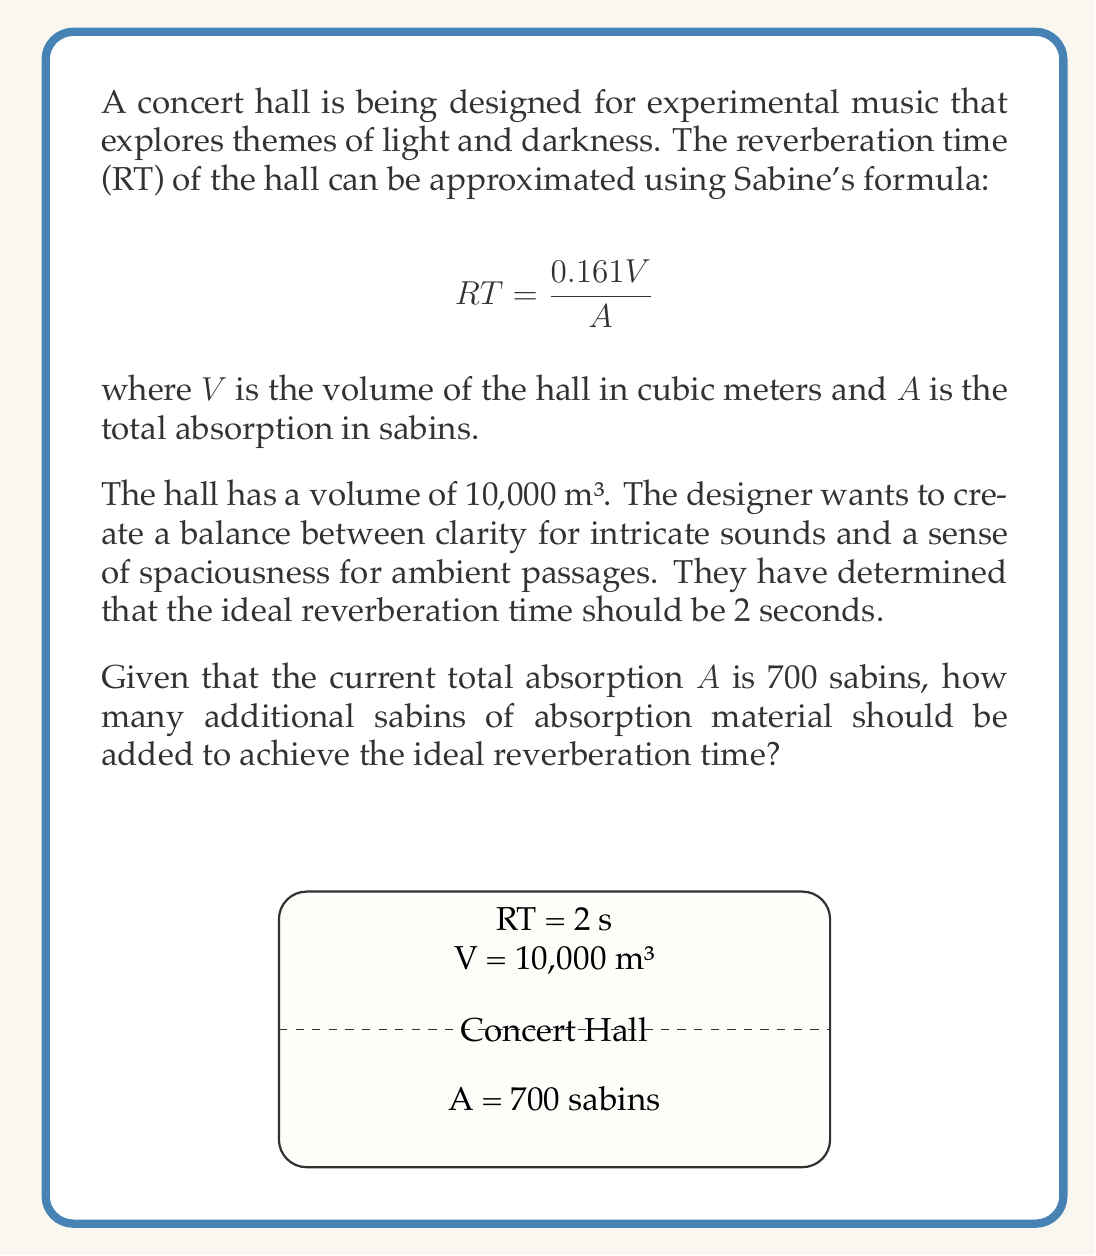Solve this math problem. Let's approach this step-by-step:

1) We start with Sabine's formula:
   $$ RT = \frac{0.161V}{A} $$

2) We know the desired RT is 2 seconds and V is 10,000 m³. Let's call the new total absorption $A_{new}$:
   $$ 2 = \frac{0.161 \cdot 10,000}{A_{new}} $$

3) Solve for $A_{new}$:
   $$ A_{new} = \frac{0.161 \cdot 10,000}{2} = 805 \text{ sabins} $$

4) The current absorption is 700 sabins, so we need to find the difference:
   $$ \text{Additional absorption} = A_{new} - A_{current} = 805 - 700 = 105 \text{ sabins} $$

Therefore, 105 sabins of additional absorption material should be added to achieve the ideal reverberation time of 2 seconds.
Answer: 105 sabins 